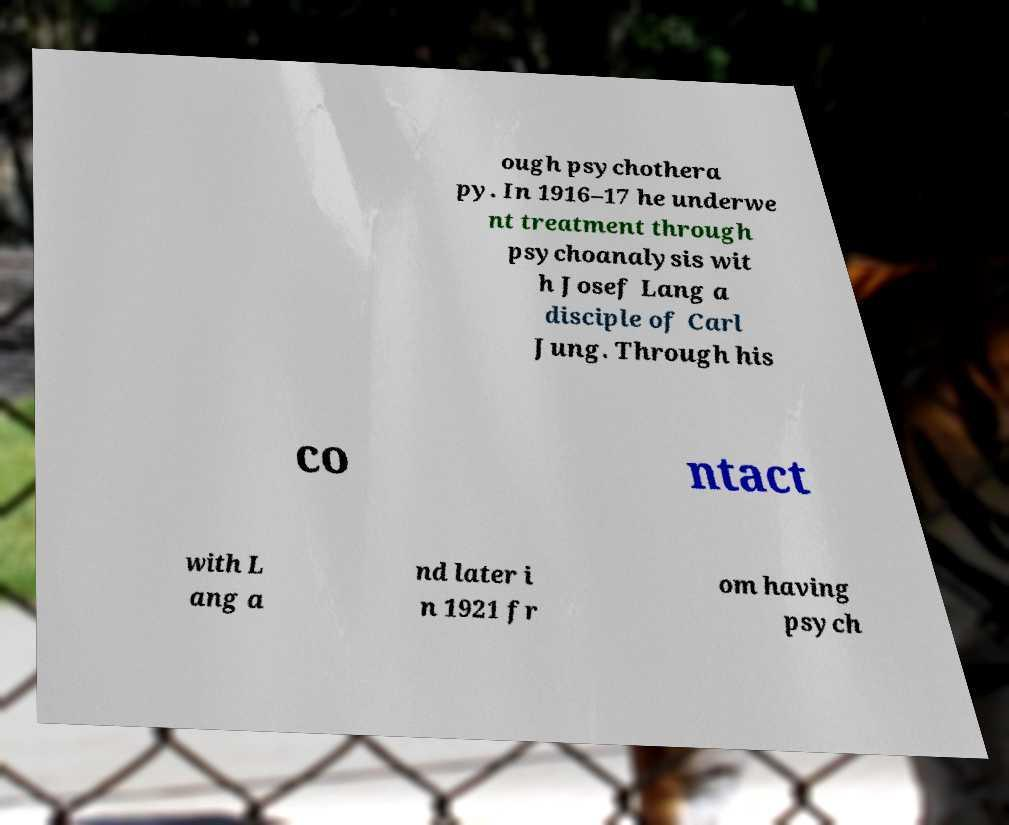Can you accurately transcribe the text from the provided image for me? ough psychothera py. In 1916–17 he underwe nt treatment through psychoanalysis wit h Josef Lang a disciple of Carl Jung. Through his co ntact with L ang a nd later i n 1921 fr om having psych 